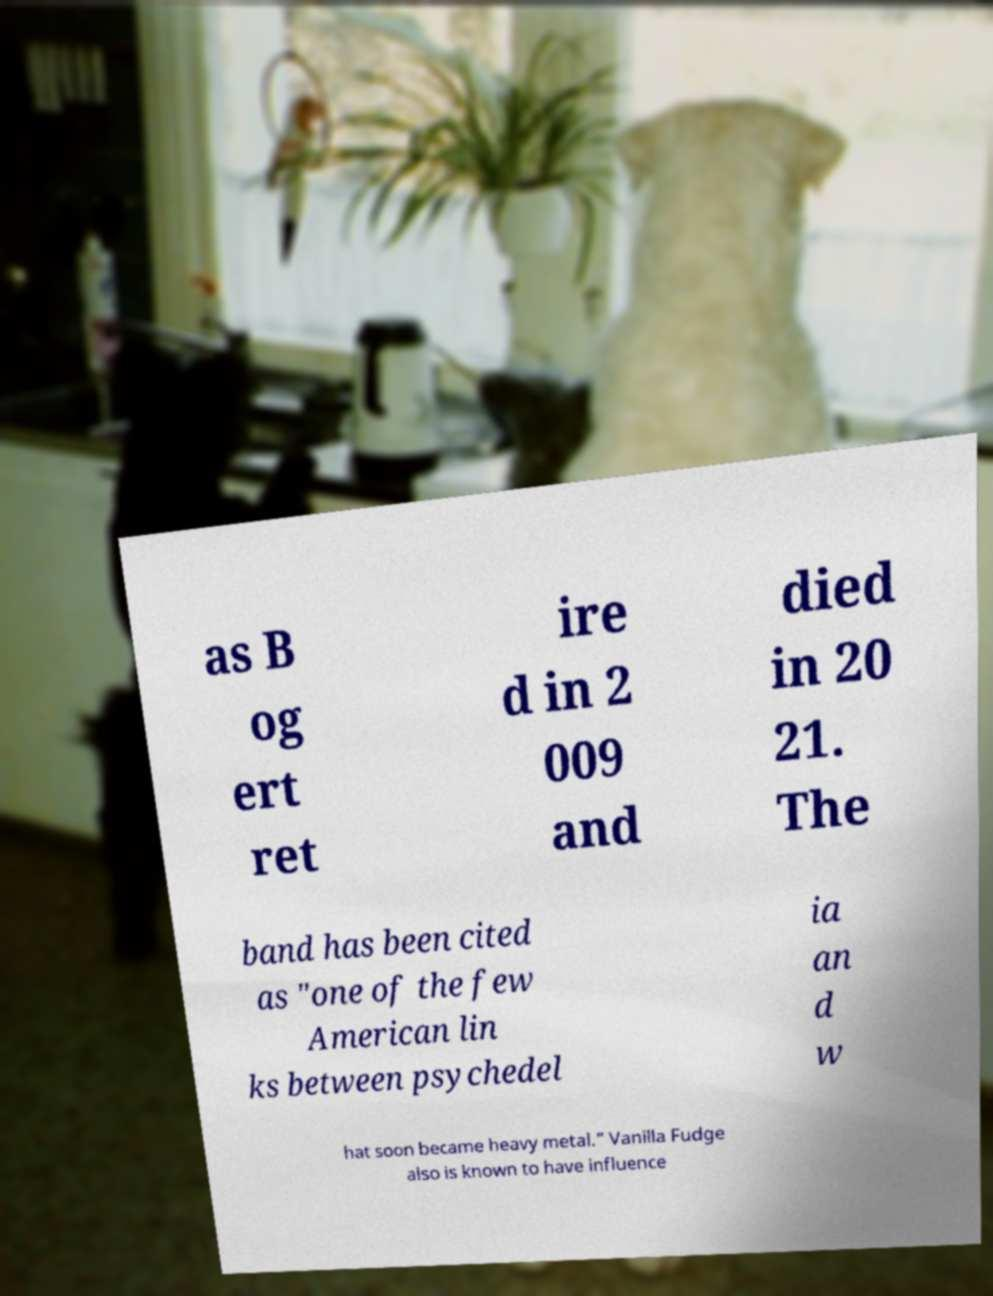Please read and relay the text visible in this image. What does it say? as B og ert ret ire d in 2 009 and died in 20 21. The band has been cited as "one of the few American lin ks between psychedel ia an d w hat soon became heavy metal." Vanilla Fudge also is known to have influence 